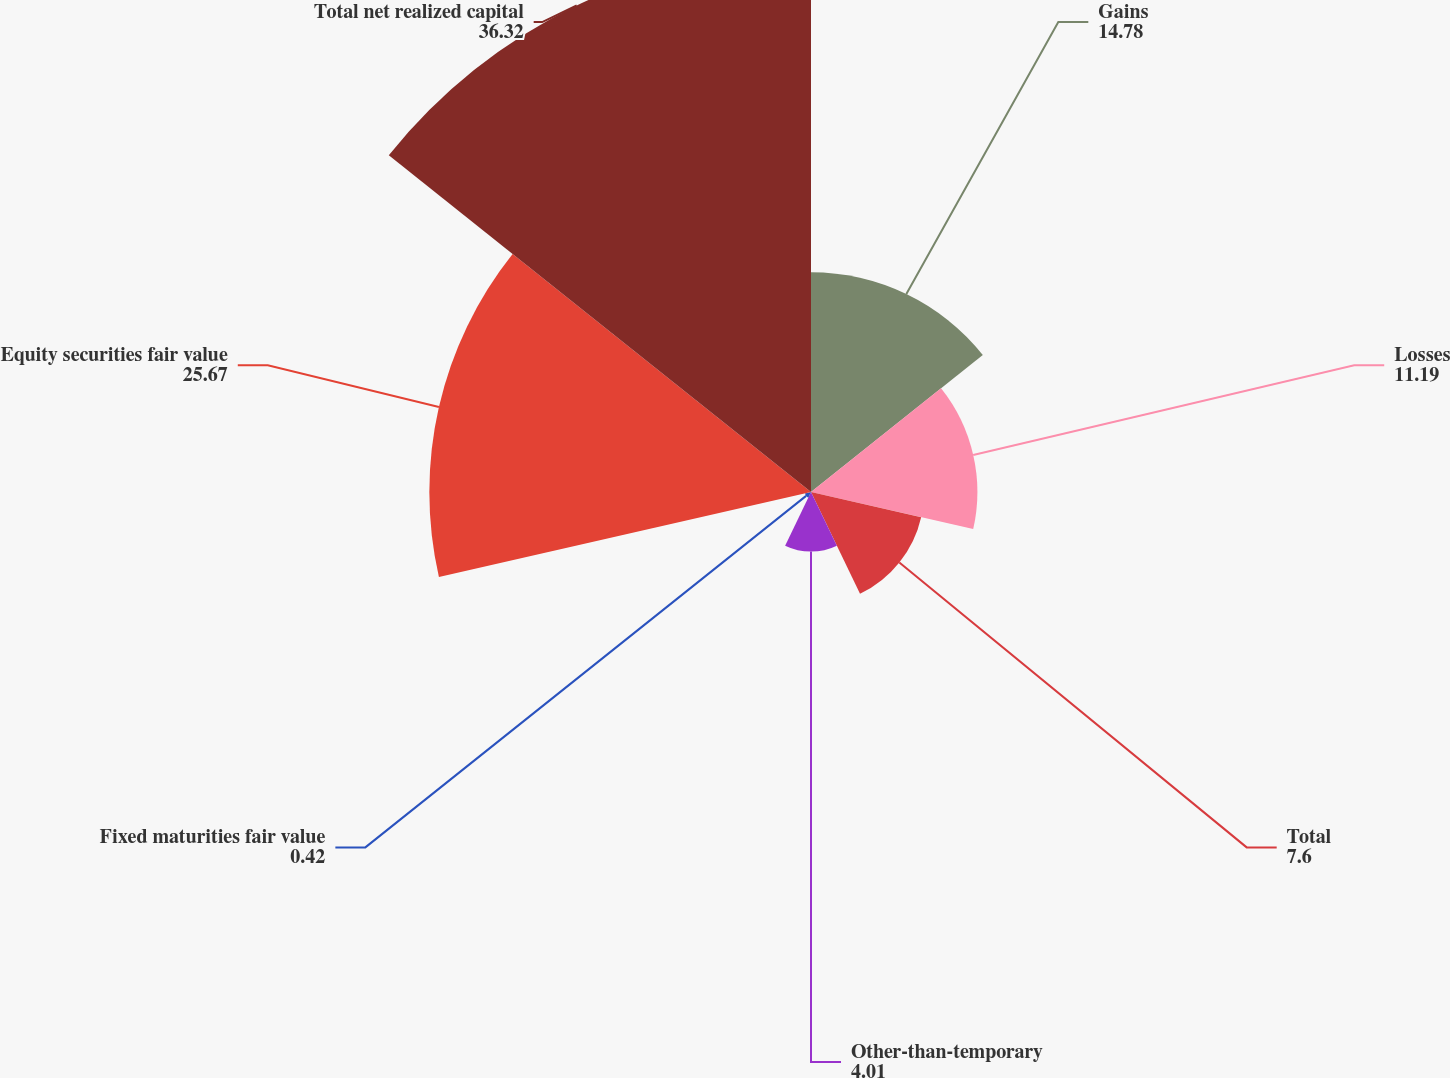Convert chart. <chart><loc_0><loc_0><loc_500><loc_500><pie_chart><fcel>Gains<fcel>Losses<fcel>Total<fcel>Other-than-temporary<fcel>Fixed maturities fair value<fcel>Equity securities fair value<fcel>Total net realized capital<nl><fcel>14.78%<fcel>11.19%<fcel>7.6%<fcel>4.01%<fcel>0.42%<fcel>25.67%<fcel>36.32%<nl></chart> 